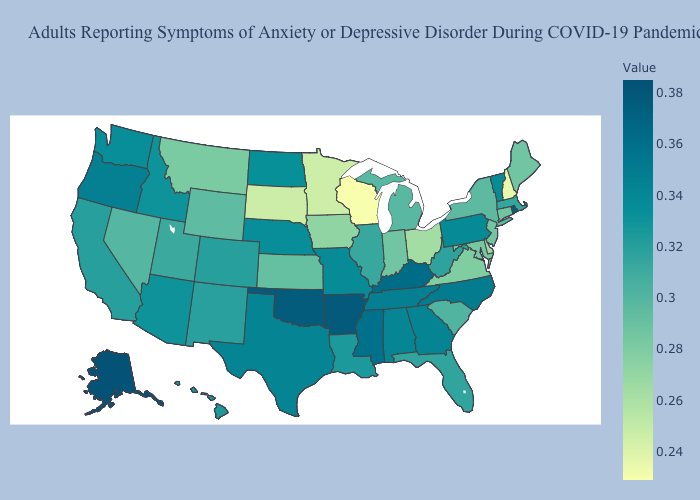Among the states that border Montana , which have the lowest value?
Keep it brief. South Dakota. Does Washington have the highest value in the USA?
Be succinct. No. Which states have the highest value in the USA?
Concise answer only. Alaska. 